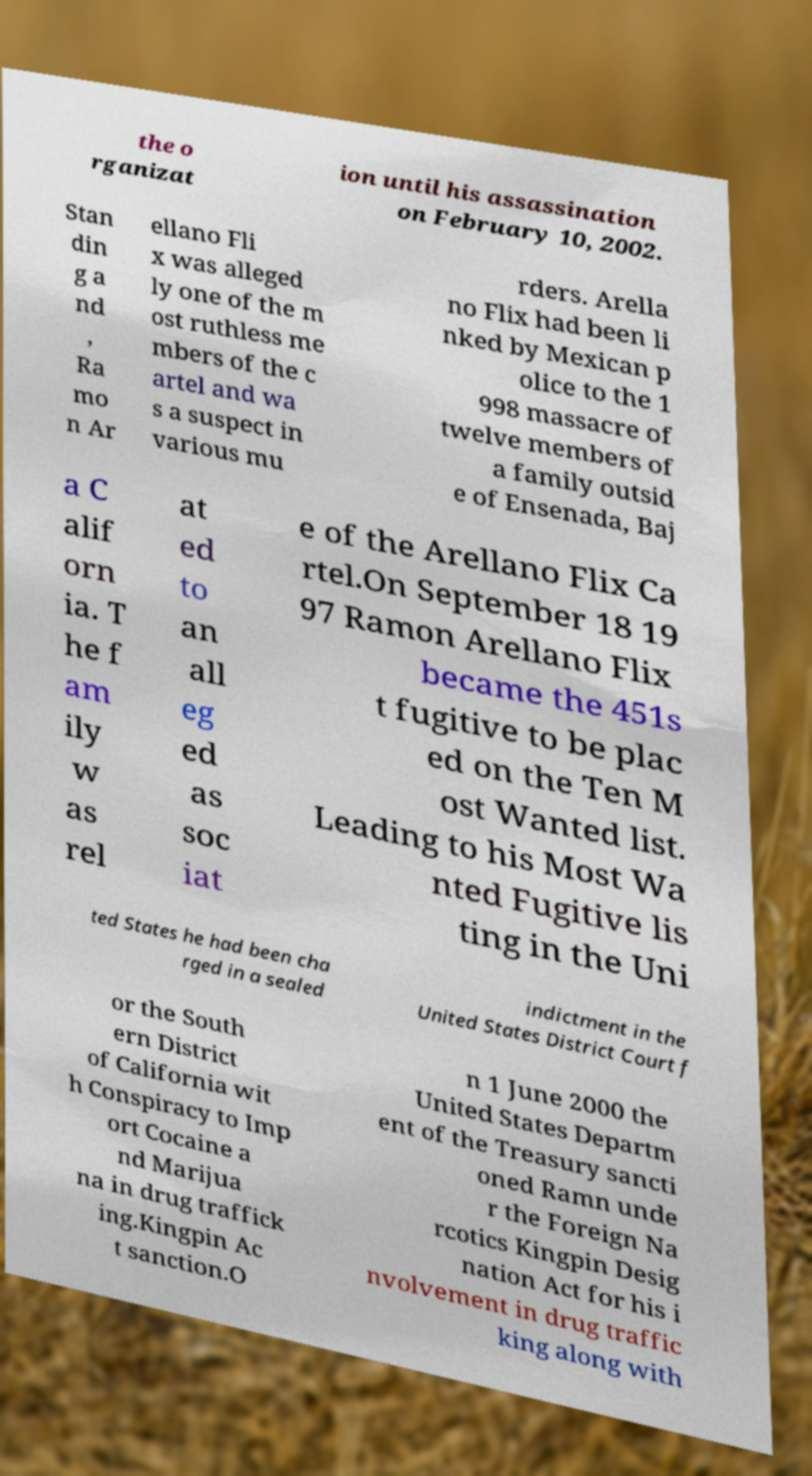What messages or text are displayed in this image? I need them in a readable, typed format. the o rganizat ion until his assassination on February 10, 2002. Stan din g a nd , Ra mo n Ar ellano Fli x was alleged ly one of the m ost ruthless me mbers of the c artel and wa s a suspect in various mu rders. Arella no Flix had been li nked by Mexican p olice to the 1 998 massacre of twelve members of a family outsid e of Ensenada, Baj a C alif orn ia. T he f am ily w as rel at ed to an all eg ed as soc iat e of the Arellano Flix Ca rtel.On September 18 19 97 Ramon Arellano Flix became the 451s t fugitive to be plac ed on the Ten M ost Wanted list. Leading to his Most Wa nted Fugitive lis ting in the Uni ted States he had been cha rged in a sealed indictment in the United States District Court f or the South ern District of California wit h Conspiracy to Imp ort Cocaine a nd Marijua na in drug traffick ing.Kingpin Ac t sanction.O n 1 June 2000 the United States Departm ent of the Treasury sancti oned Ramn unde r the Foreign Na rcotics Kingpin Desig nation Act for his i nvolvement in drug traffic king along with 